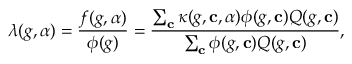<formula> <loc_0><loc_0><loc_500><loc_500>\lambda ( g , \alpha ) = \frac { f ( g , \alpha ) } { \phi ( g ) } = \frac { \sum _ { c } \kappa ( g , c , \alpha ) \phi ( g , c ) Q ( g , c ) } { \sum _ { c } \phi ( g , c ) Q ( g , c ) } ,</formula> 